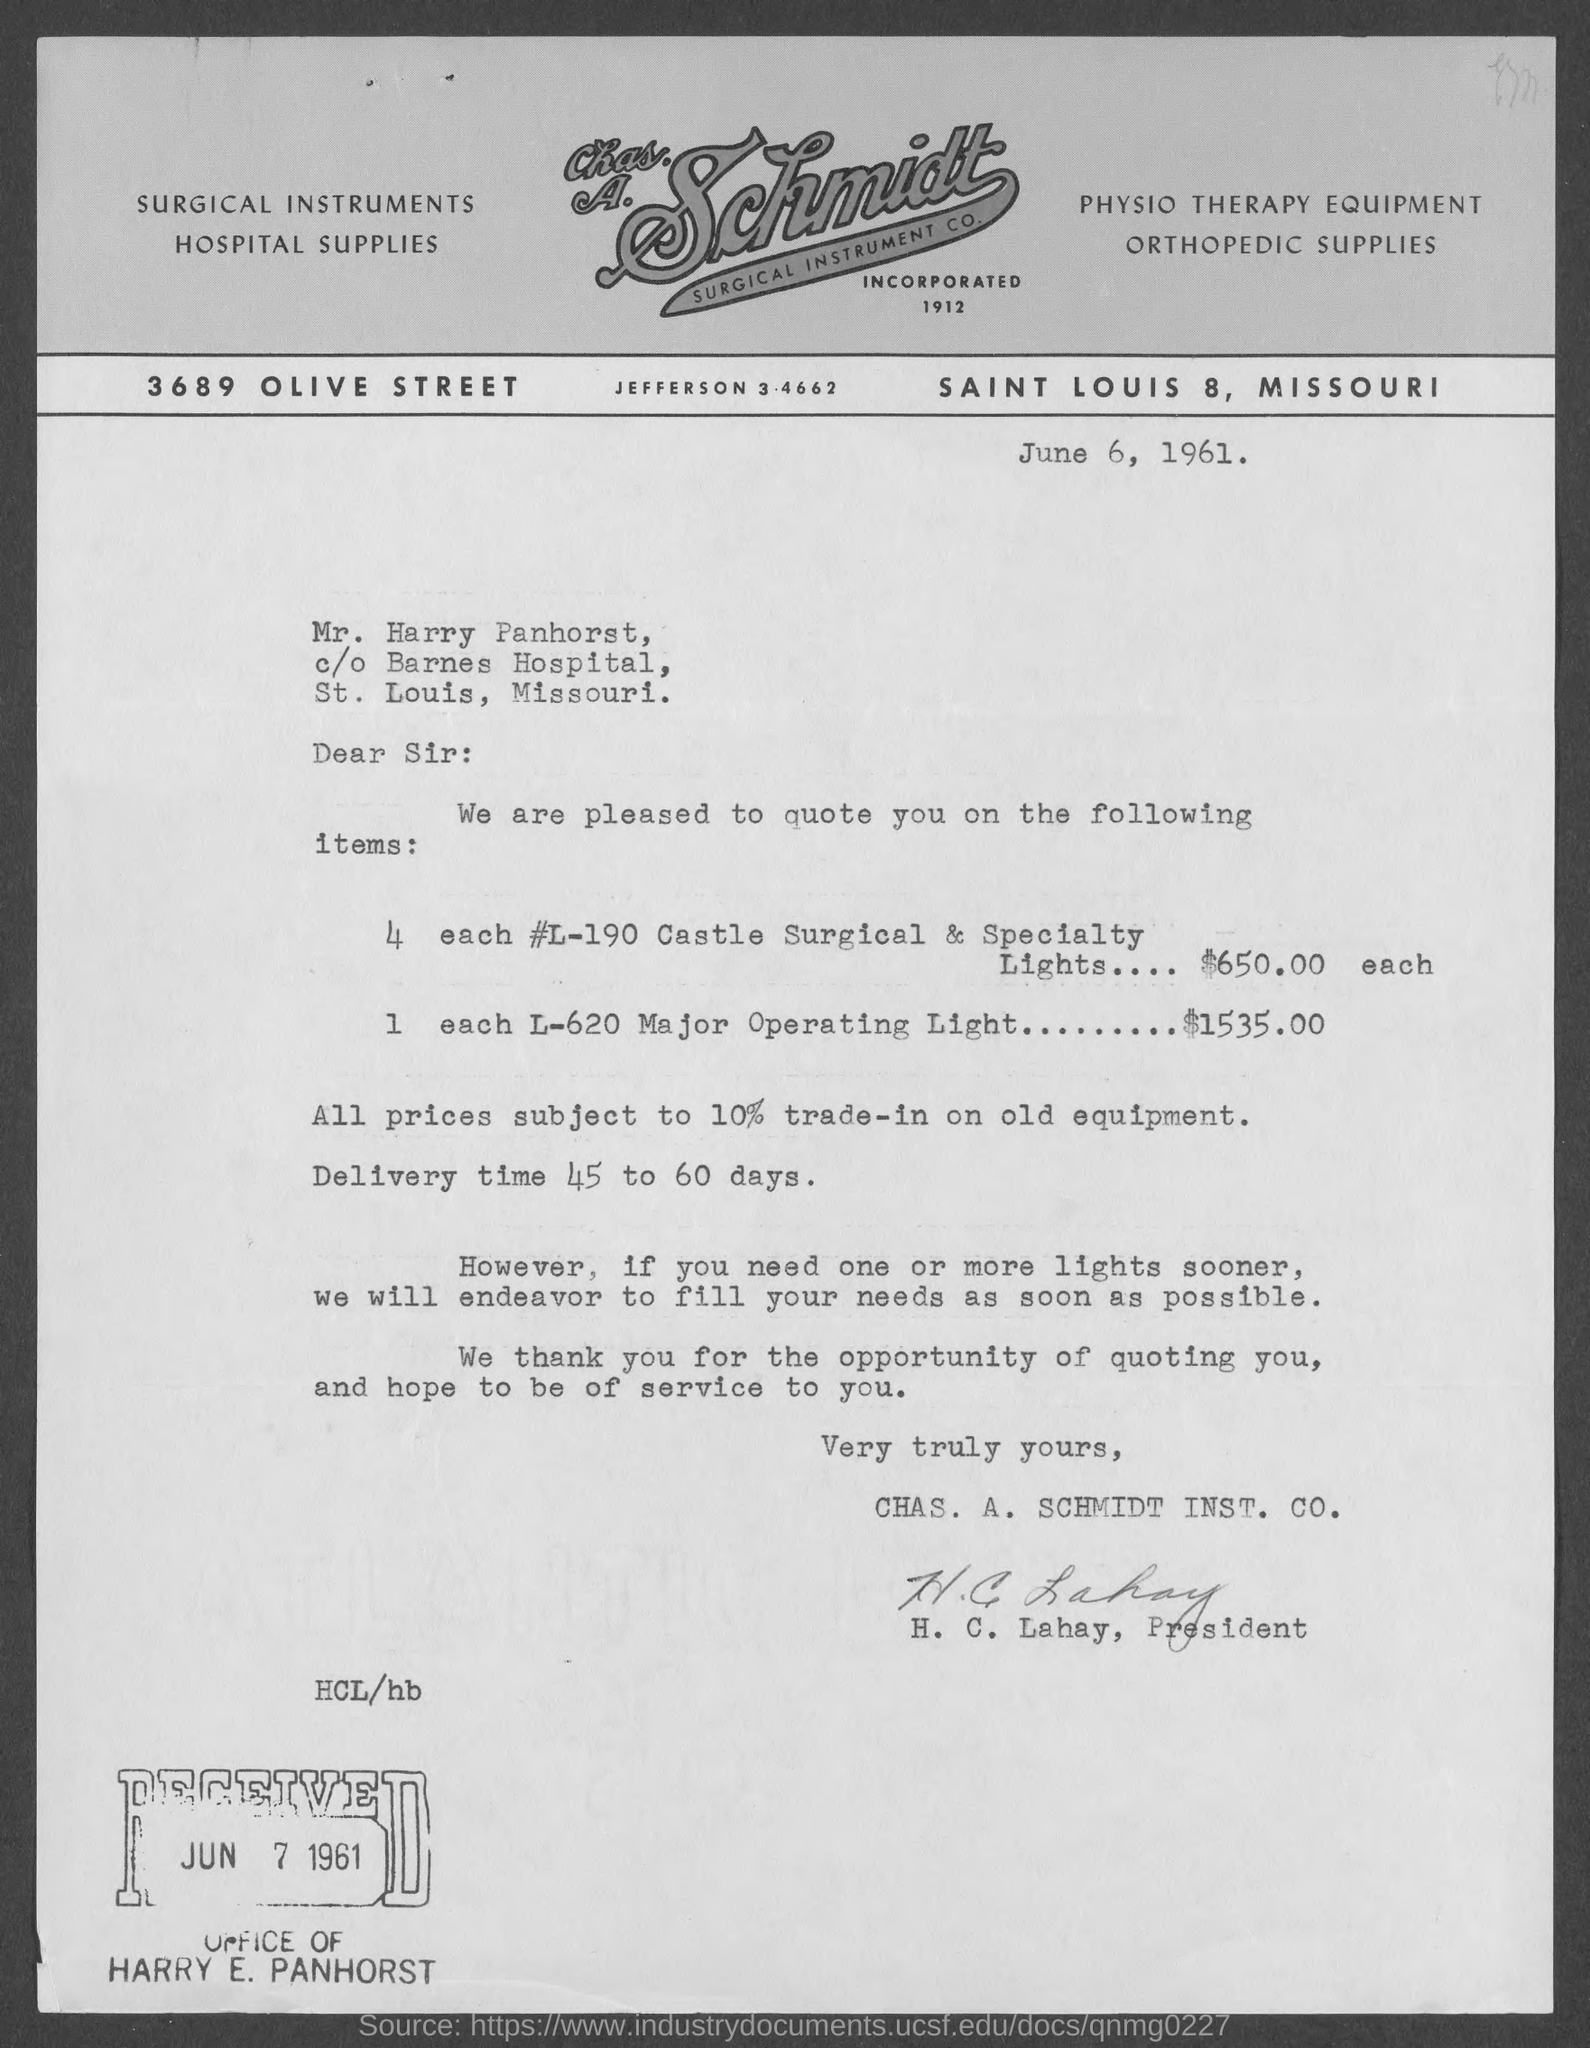Specify some key components in this picture. June 6, 1961 is the date of the document. The estimated delivery time is approximately 45 to 60 days. 